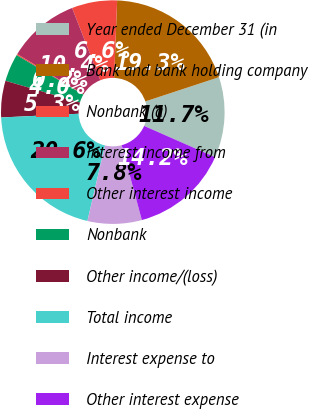Convert chart. <chart><loc_0><loc_0><loc_500><loc_500><pie_chart><fcel>Year ended December 31 (in<fcel>Bank and bank holding company<fcel>Nonbank (a)<fcel>Interest income from<fcel>Other interest income<fcel>Nonbank<fcel>Other income/(loss)<fcel>Total income<fcel>Interest expense to<fcel>Other interest expense<nl><fcel>11.66%<fcel>19.32%<fcel>6.55%<fcel>10.38%<fcel>0.17%<fcel>4.0%<fcel>5.28%<fcel>20.59%<fcel>7.83%<fcel>14.21%<nl></chart> 